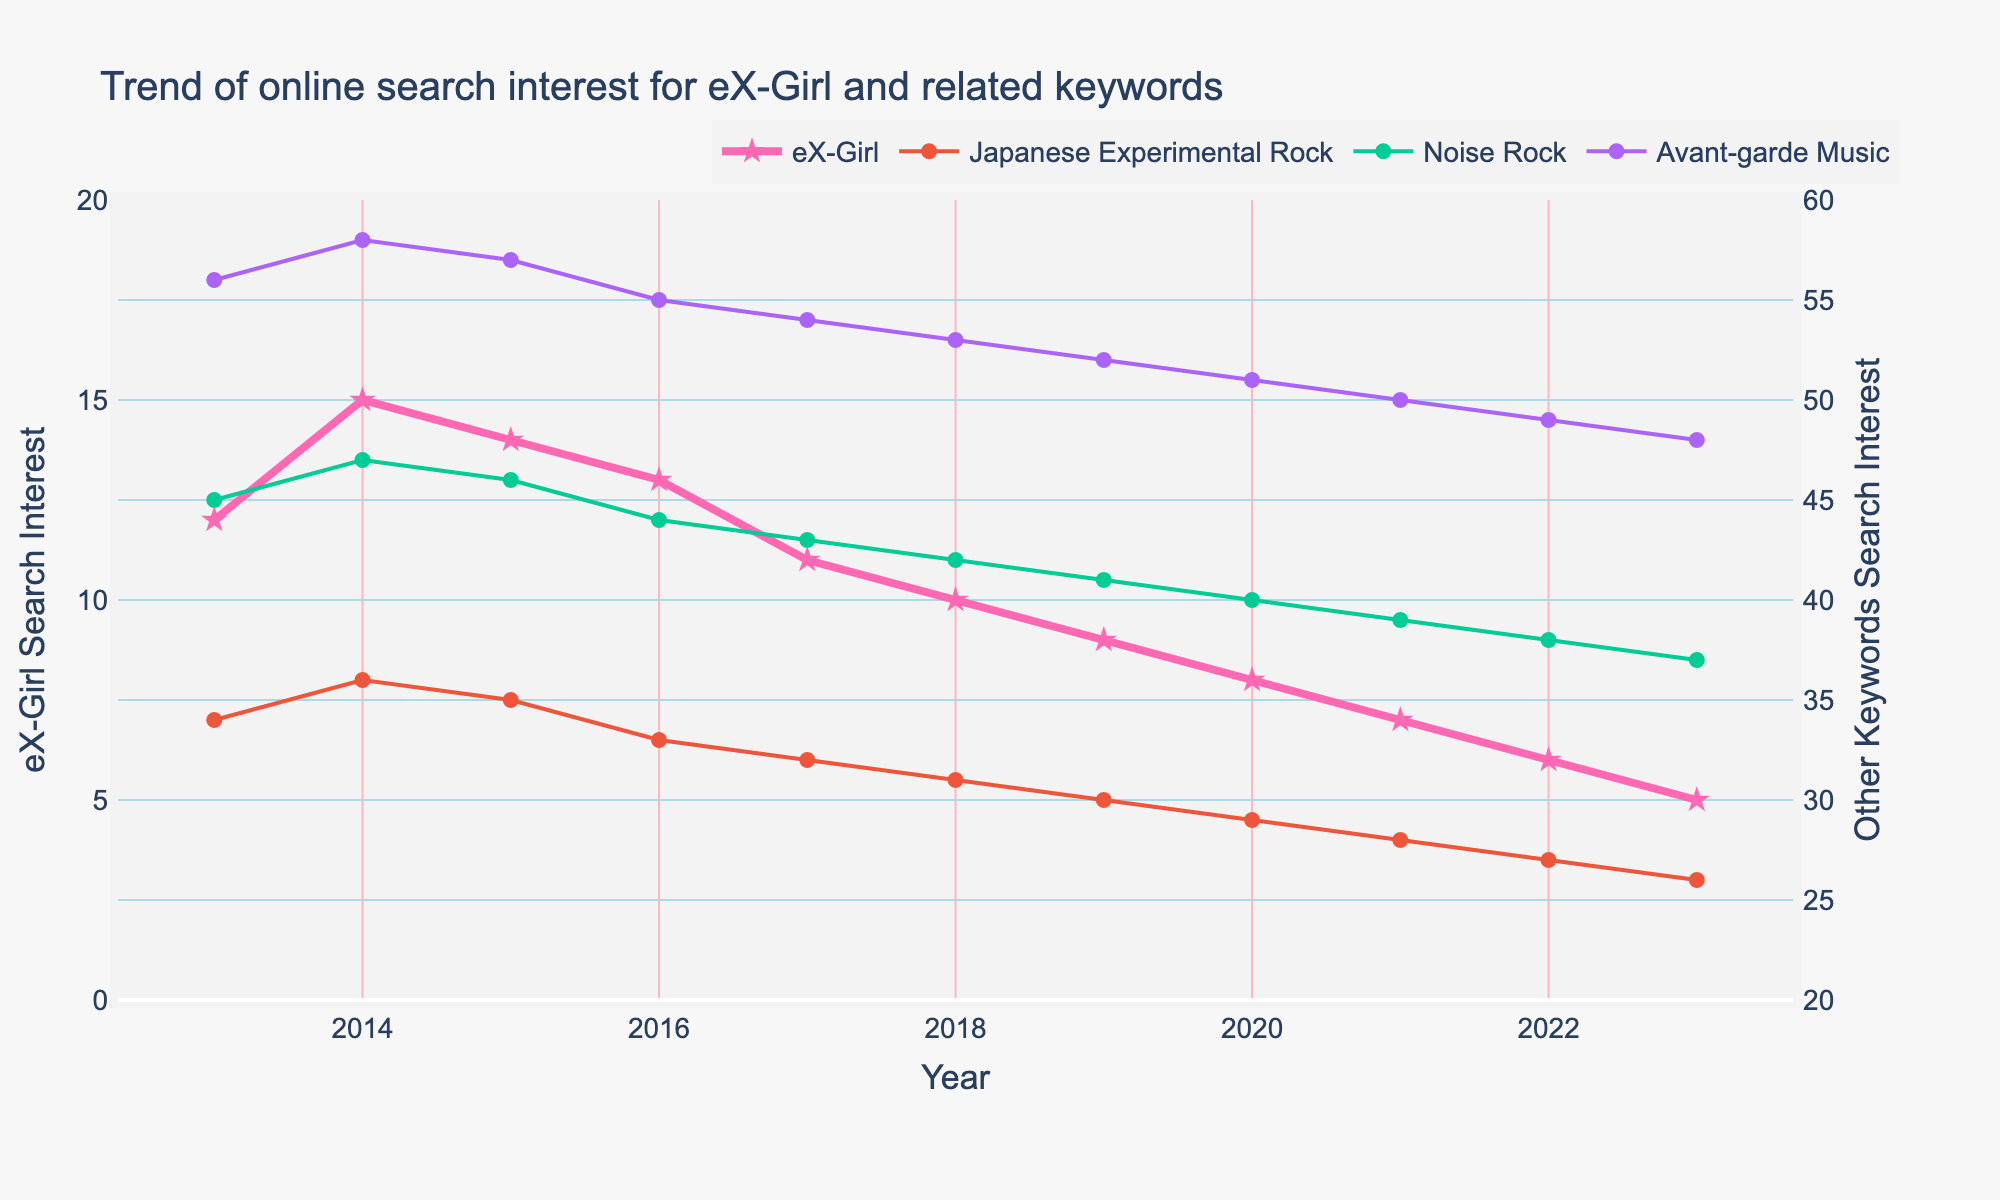What is the general trend for search interest in eX-Girl over the decade? The search interest in eX-Girl has been steadily declining from 12 in 2013 to 5 in 2023. The trend shows a gradual decrease year by year.
Answer: Declining In which year did "Japanese Experimental Rock" have the highest search interest? The visualization shows the highest search interest for "Japanese Experimental Rock" in 2014, where the value reaches 36.
Answer: 2014 How does the search interest for "Noise Rock" in 2020 compare to that for "Avant-garde Music" in the same year? The search interest for "Noise Rock" in 2020 is 40, while for "Avant-garde Music," it is 51. The interest in "Noise Rock" is lower than in "Avant-garde Music" for that year.
Answer: Noise Rock is lower What is the average search interest for eX-Girl in the first five years (2013-2017)? To calculate the average for the first five years: (12 + 15 + 14 + 13 + 11) / 5 = 13.
Answer: 13 Has any of the keywords shown an increasing trend over the decade? By examining the graph, it's clear that none of the keywords exhibit an increasing trend over the decade. All the keywords have declining trends.
Answer: No What is the difference in search interest for eX-Girl between 2013 and 2023? The search interest for eX-Girl in 2013 was 12 and in 2023 was 5. The difference is 12 - 5 = 7.
Answer: 7 Which keyword had the smallest change in search interest over the decade? Comparing the changes: Japanese Experimental Rock (34 to 26, change = 8), Noise Rock (45 to 37, change = 8), Avant-garde Music (56 to 48, change = 8). Since all the changes are equal, any can be quoted.
Answer: All non-eX-Girl keywords have equal change In 2021, how does the search interest in eX-Girl compare to the search interest in "Noise Rock"? In 2021, the search interest in eX-Girl is 7, whereas for "Noise Rock" it is 39. The interest in eX-Girl is much lower.
Answer: Lower What is the trend slope for search interest in eX-Girl from 2013 to 2023? The slope can be calculated as (change in value) / (change in time). For eX-Girl, it is (5 - 12) / (2023 - 2013) = -7/10 = -0.7 per year.
Answer: -0.7 per year 